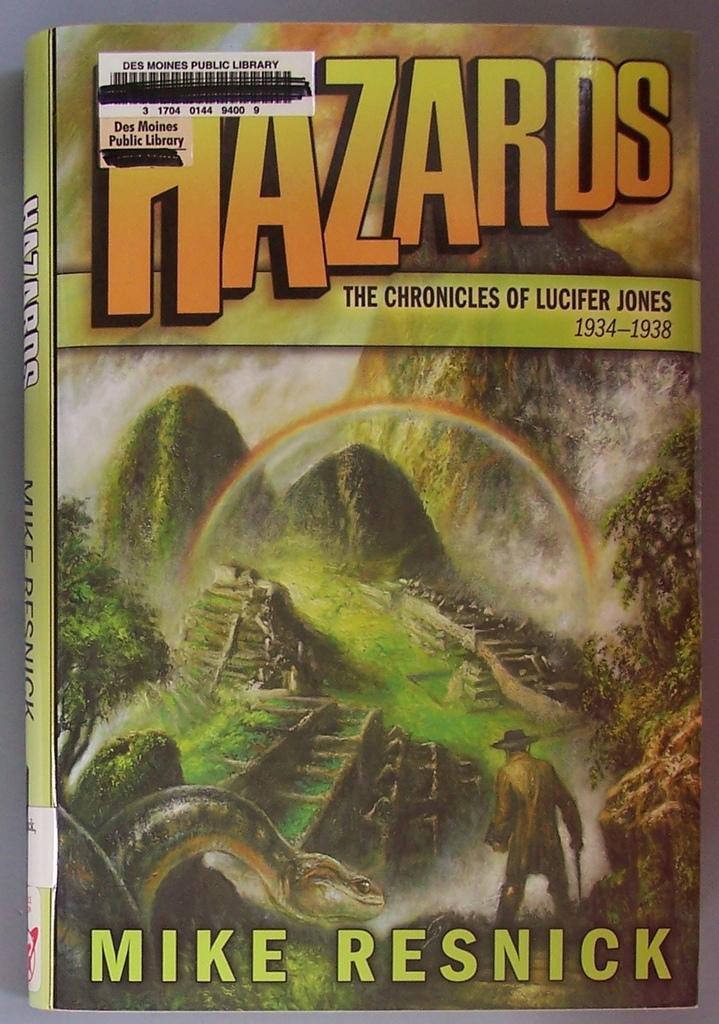Provide a one-sentence caption for the provided image. Cover of a book named Hazards by Mike Resnick. 